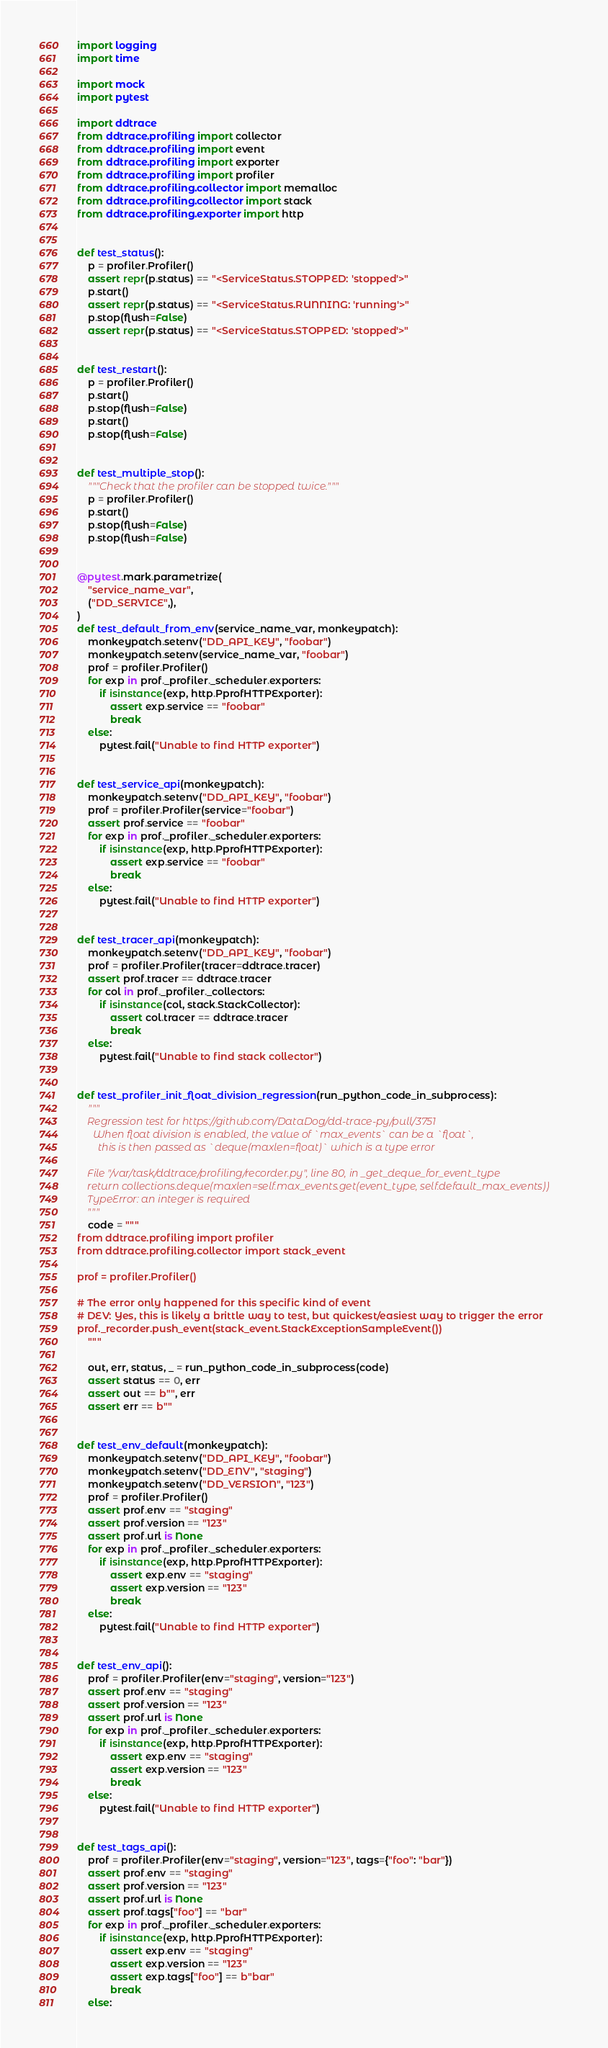<code> <loc_0><loc_0><loc_500><loc_500><_Python_>import logging
import time

import mock
import pytest

import ddtrace
from ddtrace.profiling import collector
from ddtrace.profiling import event
from ddtrace.profiling import exporter
from ddtrace.profiling import profiler
from ddtrace.profiling.collector import memalloc
from ddtrace.profiling.collector import stack
from ddtrace.profiling.exporter import http


def test_status():
    p = profiler.Profiler()
    assert repr(p.status) == "<ServiceStatus.STOPPED: 'stopped'>"
    p.start()
    assert repr(p.status) == "<ServiceStatus.RUNNING: 'running'>"
    p.stop(flush=False)
    assert repr(p.status) == "<ServiceStatus.STOPPED: 'stopped'>"


def test_restart():
    p = profiler.Profiler()
    p.start()
    p.stop(flush=False)
    p.start()
    p.stop(flush=False)


def test_multiple_stop():
    """Check that the profiler can be stopped twice."""
    p = profiler.Profiler()
    p.start()
    p.stop(flush=False)
    p.stop(flush=False)


@pytest.mark.parametrize(
    "service_name_var",
    ("DD_SERVICE",),
)
def test_default_from_env(service_name_var, monkeypatch):
    monkeypatch.setenv("DD_API_KEY", "foobar")
    monkeypatch.setenv(service_name_var, "foobar")
    prof = profiler.Profiler()
    for exp in prof._profiler._scheduler.exporters:
        if isinstance(exp, http.PprofHTTPExporter):
            assert exp.service == "foobar"
            break
    else:
        pytest.fail("Unable to find HTTP exporter")


def test_service_api(monkeypatch):
    monkeypatch.setenv("DD_API_KEY", "foobar")
    prof = profiler.Profiler(service="foobar")
    assert prof.service == "foobar"
    for exp in prof._profiler._scheduler.exporters:
        if isinstance(exp, http.PprofHTTPExporter):
            assert exp.service == "foobar"
            break
    else:
        pytest.fail("Unable to find HTTP exporter")


def test_tracer_api(monkeypatch):
    monkeypatch.setenv("DD_API_KEY", "foobar")
    prof = profiler.Profiler(tracer=ddtrace.tracer)
    assert prof.tracer == ddtrace.tracer
    for col in prof._profiler._collectors:
        if isinstance(col, stack.StackCollector):
            assert col.tracer == ddtrace.tracer
            break
    else:
        pytest.fail("Unable to find stack collector")


def test_profiler_init_float_division_regression(run_python_code_in_subprocess):
    """
    Regression test for https://github.com/DataDog/dd-trace-py/pull/3751
      When float division is enabled, the value of `max_events` can be a `float`,
        this is then passed as `deque(maxlen=float)` which is a type error

    File "/var/task/ddtrace/profiling/recorder.py", line 80, in _get_deque_for_event_type
    return collections.deque(maxlen=self.max_events.get(event_type, self.default_max_events))
    TypeError: an integer is required
    """
    code = """
from ddtrace.profiling import profiler
from ddtrace.profiling.collector import stack_event

prof = profiler.Profiler()

# The error only happened for this specific kind of event
# DEV: Yes, this is likely a brittle way to test, but quickest/easiest way to trigger the error
prof._recorder.push_event(stack_event.StackExceptionSampleEvent())
    """

    out, err, status, _ = run_python_code_in_subprocess(code)
    assert status == 0, err
    assert out == b"", err
    assert err == b""


def test_env_default(monkeypatch):
    monkeypatch.setenv("DD_API_KEY", "foobar")
    monkeypatch.setenv("DD_ENV", "staging")
    monkeypatch.setenv("DD_VERSION", "123")
    prof = profiler.Profiler()
    assert prof.env == "staging"
    assert prof.version == "123"
    assert prof.url is None
    for exp in prof._profiler._scheduler.exporters:
        if isinstance(exp, http.PprofHTTPExporter):
            assert exp.env == "staging"
            assert exp.version == "123"
            break
    else:
        pytest.fail("Unable to find HTTP exporter")


def test_env_api():
    prof = profiler.Profiler(env="staging", version="123")
    assert prof.env == "staging"
    assert prof.version == "123"
    assert prof.url is None
    for exp in prof._profiler._scheduler.exporters:
        if isinstance(exp, http.PprofHTTPExporter):
            assert exp.env == "staging"
            assert exp.version == "123"
            break
    else:
        pytest.fail("Unable to find HTTP exporter")


def test_tags_api():
    prof = profiler.Profiler(env="staging", version="123", tags={"foo": "bar"})
    assert prof.env == "staging"
    assert prof.version == "123"
    assert prof.url is None
    assert prof.tags["foo"] == "bar"
    for exp in prof._profiler._scheduler.exporters:
        if isinstance(exp, http.PprofHTTPExporter):
            assert exp.env == "staging"
            assert exp.version == "123"
            assert exp.tags["foo"] == b"bar"
            break
    else:</code> 